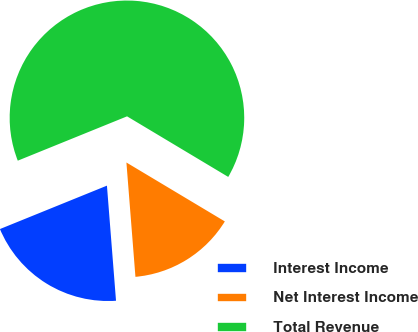Convert chart. <chart><loc_0><loc_0><loc_500><loc_500><pie_chart><fcel>Interest Income<fcel>Net Interest Income<fcel>Total Revenue<nl><fcel>20.12%<fcel>15.16%<fcel>64.72%<nl></chart> 